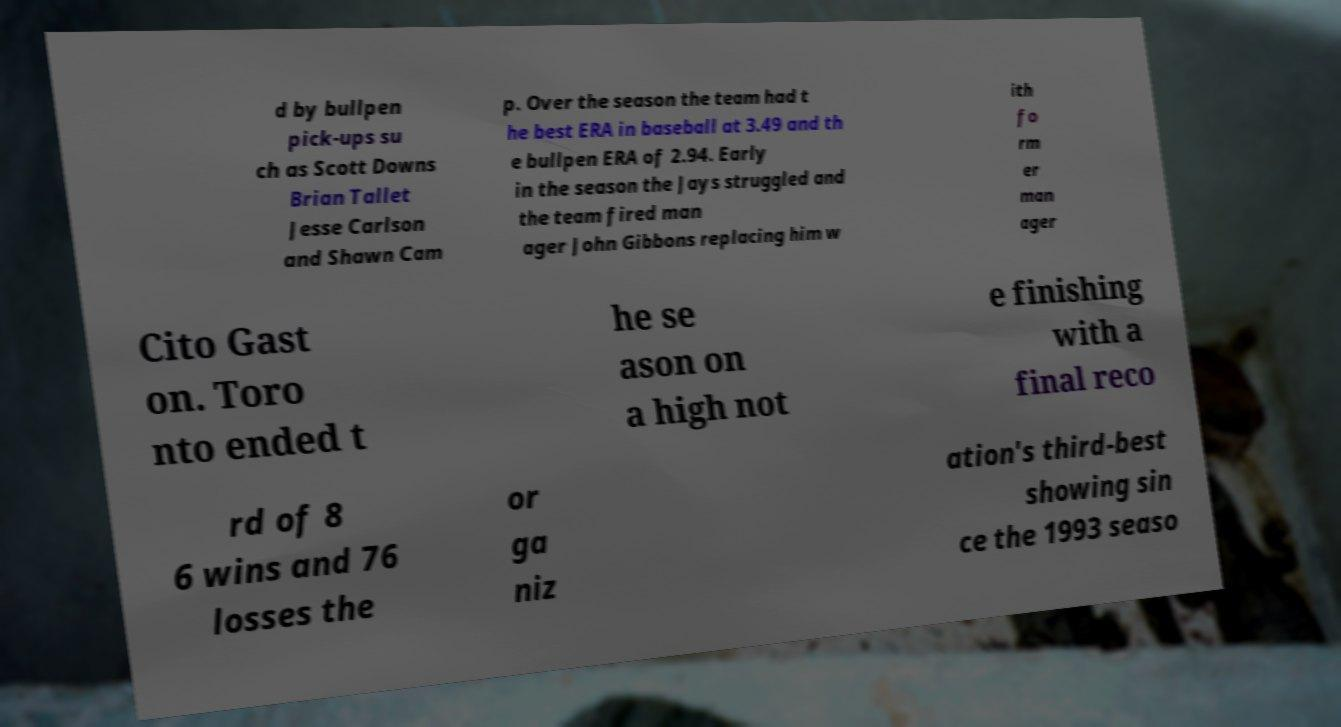Could you extract and type out the text from this image? d by bullpen pick-ups su ch as Scott Downs Brian Tallet Jesse Carlson and Shawn Cam p. Over the season the team had t he best ERA in baseball at 3.49 and th e bullpen ERA of 2.94. Early in the season the Jays struggled and the team fired man ager John Gibbons replacing him w ith fo rm er man ager Cito Gast on. Toro nto ended t he se ason on a high not e finishing with a final reco rd of 8 6 wins and 76 losses the or ga niz ation's third-best showing sin ce the 1993 seaso 